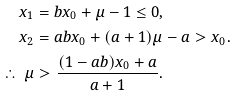Convert formula to latex. <formula><loc_0><loc_0><loc_500><loc_500>x _ { 1 } & = b x _ { 0 } + \mu - 1 \leq 0 , \\ x _ { 2 } & = a b x _ { 0 } + ( a + 1 ) \mu - a > x _ { 0 } . \\ \therefore \, \mu & > \frac { ( 1 - a b ) x _ { 0 } + a } { a + 1 } .</formula> 